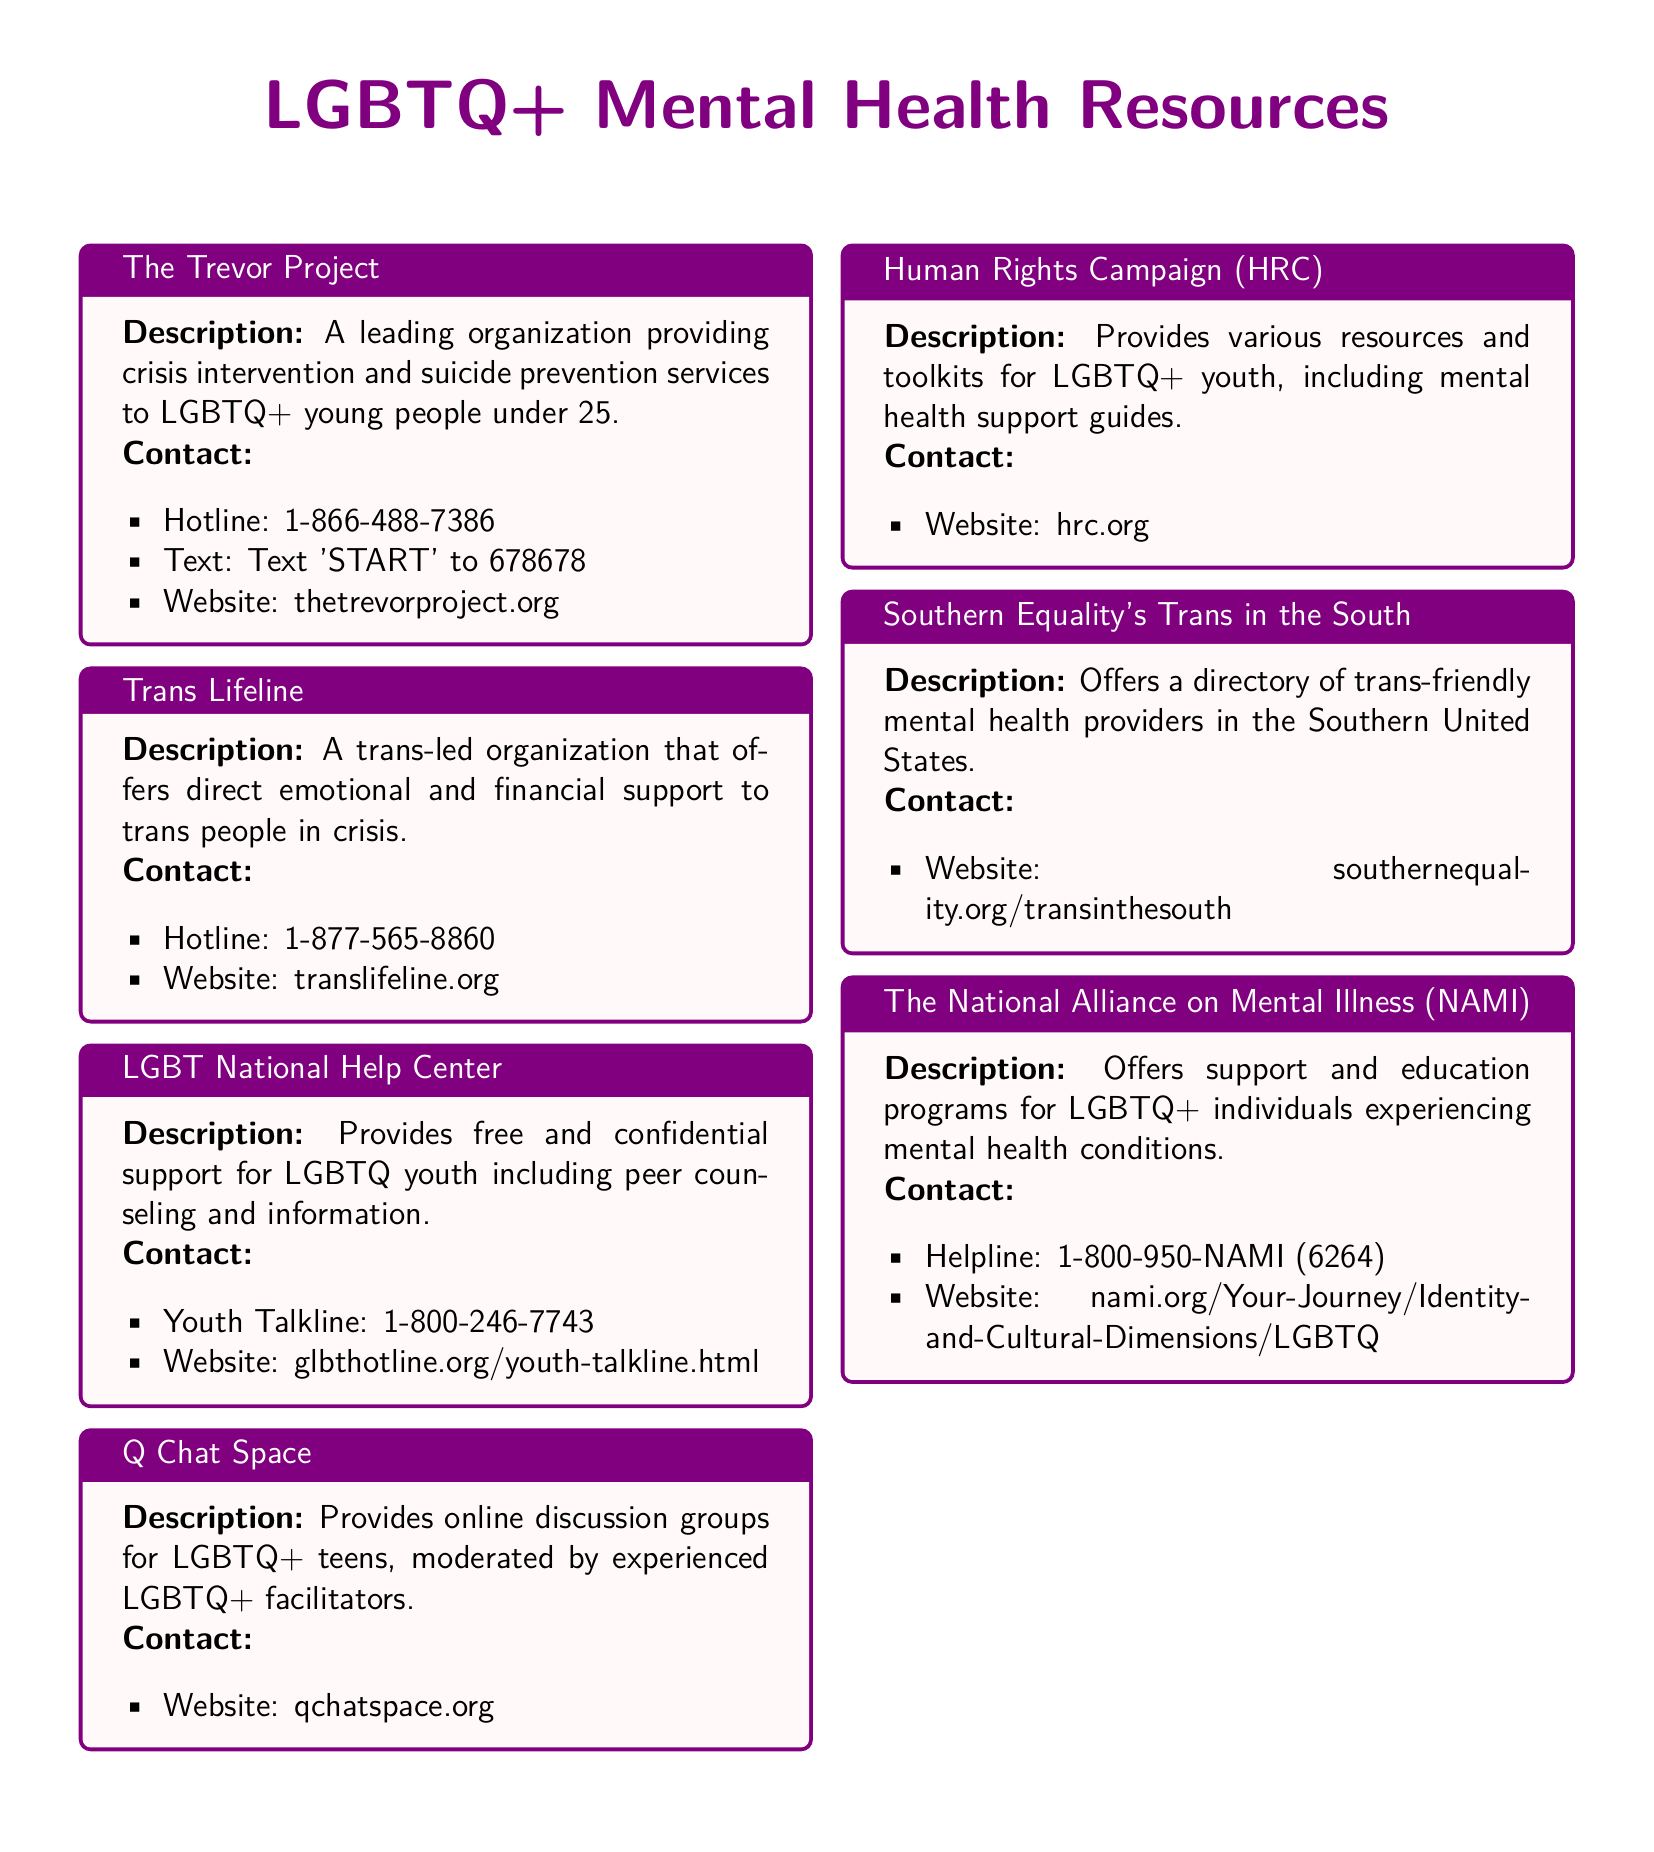What is the hotline number for The Trevor Project? The hotline number for The Trevor Project is specified in the document.
Answer: 1-866-488-7386 What organization provides a youth talkline? The document lists multiple organizations, but specifically mentions the LGBT National Help Center for a youth talkline.
Answer: LGBT National Help Center Which organization offers a directory of trans-friendly mental health providers? This requires knowledge of the specific organization identified in the document.
Answer: Southern Equality's Trans in the South What service type does Q Chat Space provide? The service type for Q Chat Space is described in the document.
Answer: Online discussion groups What is the website for Trans Lifeline? The document specifies the website for Trans Lifeline.
Answer: translifeline.org Which organization has a helpline number related to mental health conditions for LGBTQ+ individuals? The helpline number is associated with a specific organization mentioned in the document.
Answer: The National Alliance on Mental Illness (NAMI) How can you contact the Human Rights Campaign (HRC)? The contact method for HRC is stated in the document.
Answer: hrc.org What is the purpose of The National Alliance on Mental Illness (NAMI)? Reasoning about the focus of NAMI based on the description.
Answer: Support and education programs What age group does The Trevor Project serve? The document provides the age range that The Trevor Project focuses on.
Answer: Under 25 